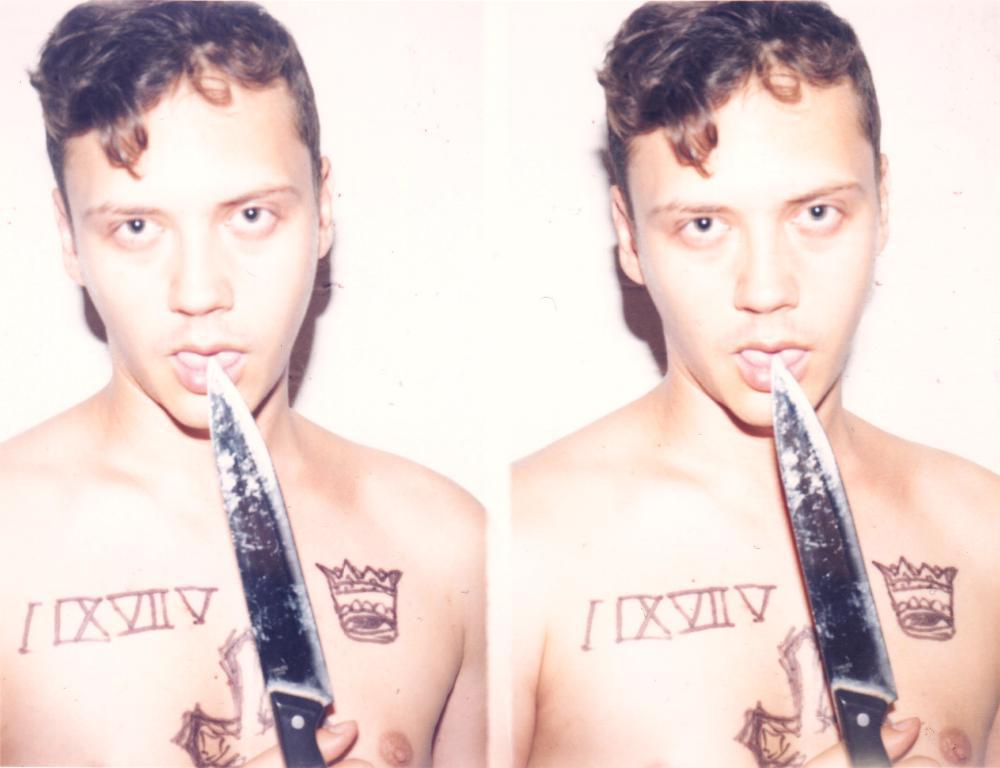What type of artwork is depicted in the image? The image is a collage. Can you describe the main subject of the collage? There is a man in the image. What is the man doing in the image? The man is holding a knife near his mouth. Are there any visible features on the man's body? Yes, the man has tattoos on his chest. What color is the background of the image? The background of the image is white. What type of alley can be seen in the background of the image? There is no alley present in the image; the background is white. How does the man use the spring to enhance his performance in the image? There is no spring or performance depicted in the image; it features a man holding a knife near his mouth. 